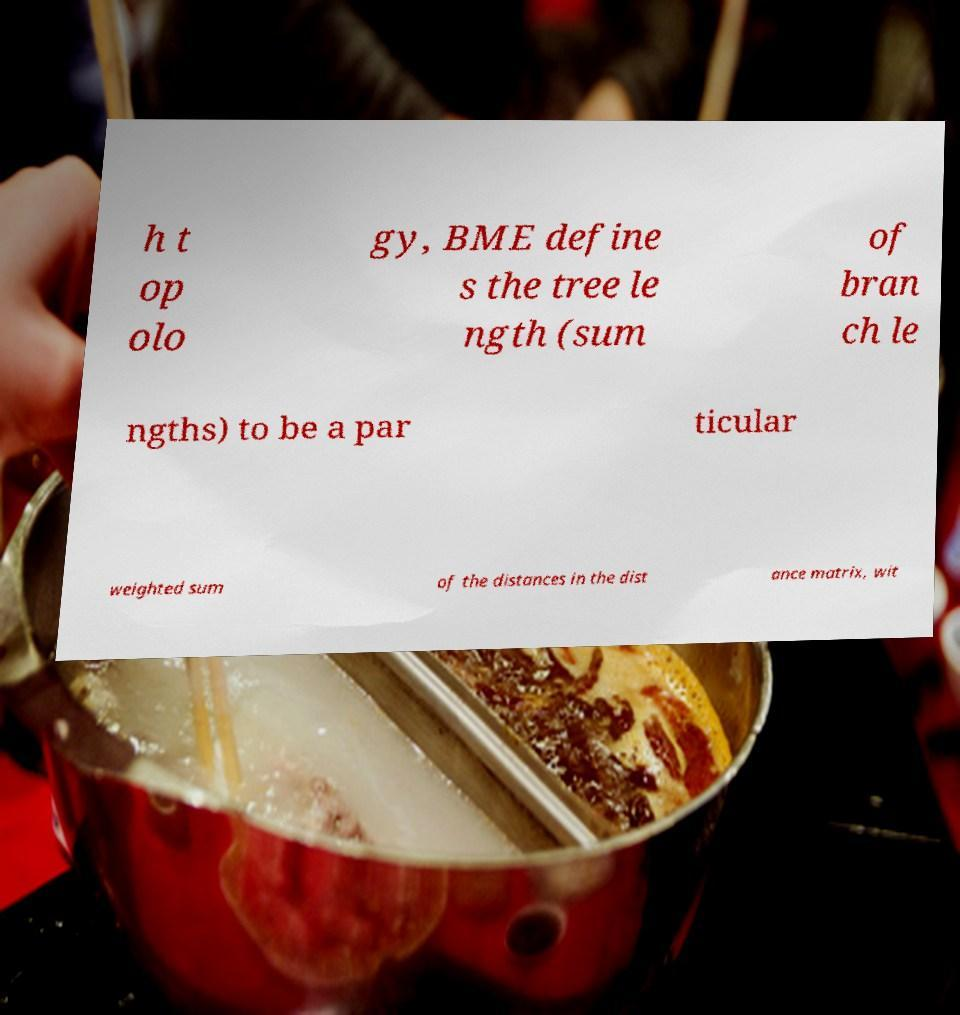I need the written content from this picture converted into text. Can you do that? h t op olo gy, BME define s the tree le ngth (sum of bran ch le ngths) to be a par ticular weighted sum of the distances in the dist ance matrix, wit 